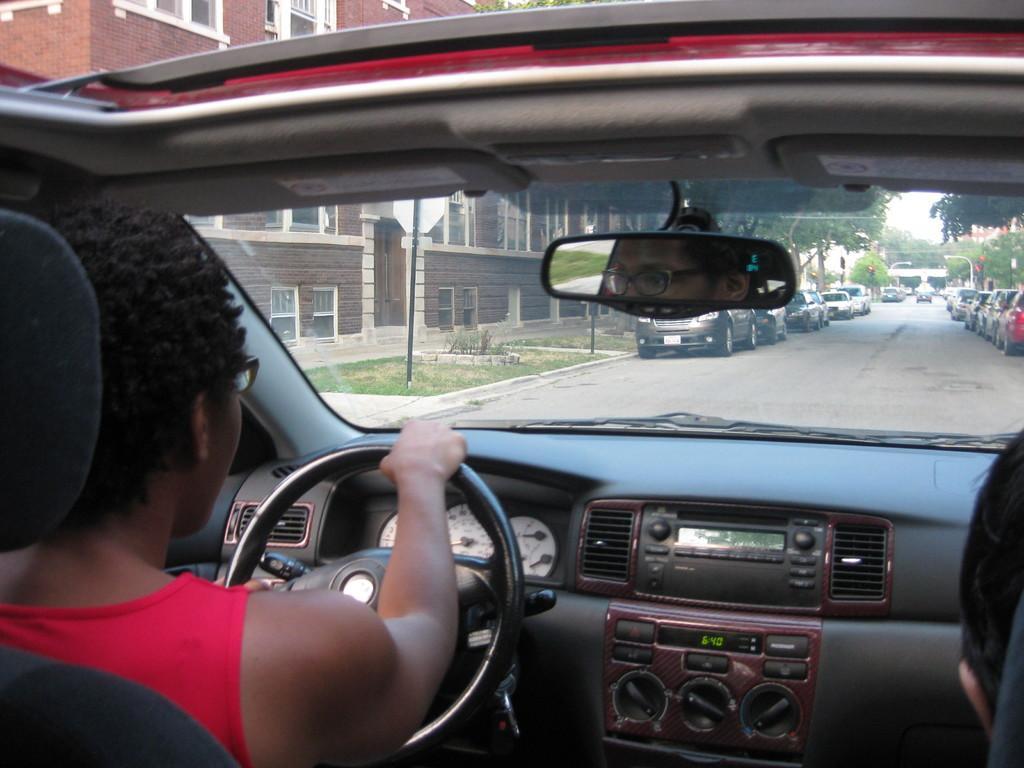In one or two sentences, can you explain what this image depicts? In the image we can see inside of the vehicle. In the vehicle a person is sitting and driving. Through the windshield we can see some vehicles on the road and there are some trees and buildings and poles and sign boards. 